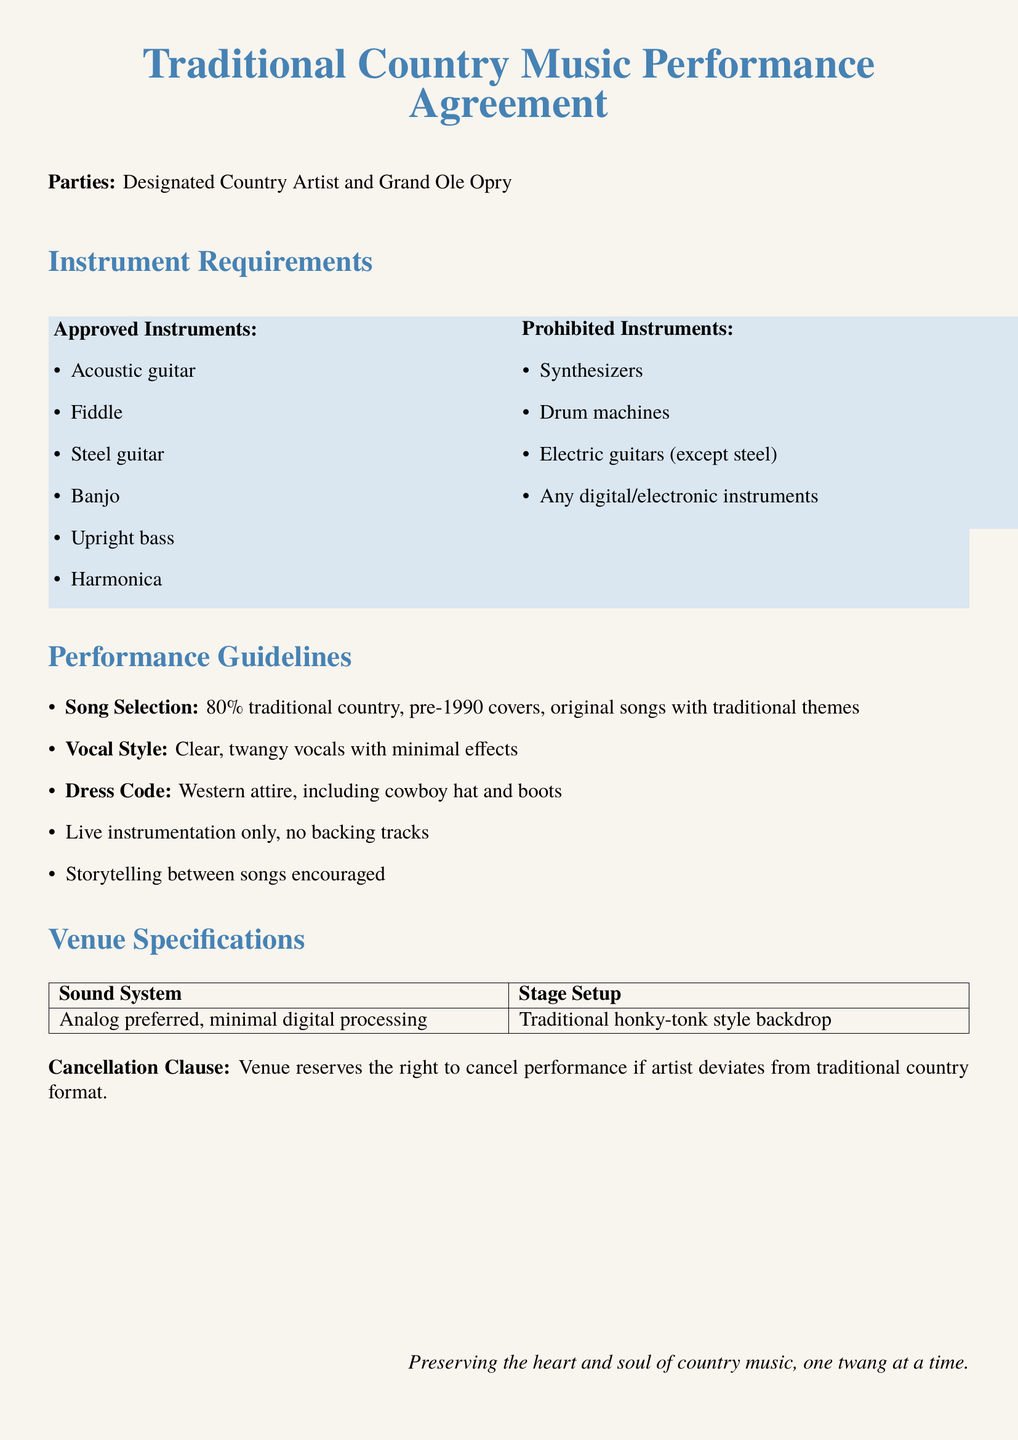What is the title of the document? The title is clearly mentioned at the top of the document, indicating the focus of the agreement.
Answer: Traditional Country Music Performance Agreement Who are the parties involved? The parties are specified right after the title, listing the designations involved in the agreement.
Answer: Designated Country Artist and Grand Ole Opry What percentage of songs must be traditional country? This is detailed in the performance guidelines section, specifying the required percentage.
Answer: 80% Which instrument is prohibited from performances? The document lists instruments that are not allowed in performances, providing clarity on restrictions.
Answer: Synthesizers What must the dress code include? The dress code is outlined in the performance guidelines and highlights specific attire that must be worn.
Answer: Cowboy hat and boots What type of sound system is preferred? The venue specifications section indicates the preferred sound system type for performances.
Answer: Analog preferred Is live instrumentation mandatory? It is clearly stated in the performance guidelines, emphasizing the requirements for live performance setups.
Answer: Yes What is encouraged between songs? This is mentioned in the performance guidelines, suggesting an element of storytelling is part of the performance culture.
Answer: Storytelling What is the cancellation clause related to? The cancellation clause summarizes the conditions under which the venue can cancel a performance.
Answer: Deviation from traditional country format 